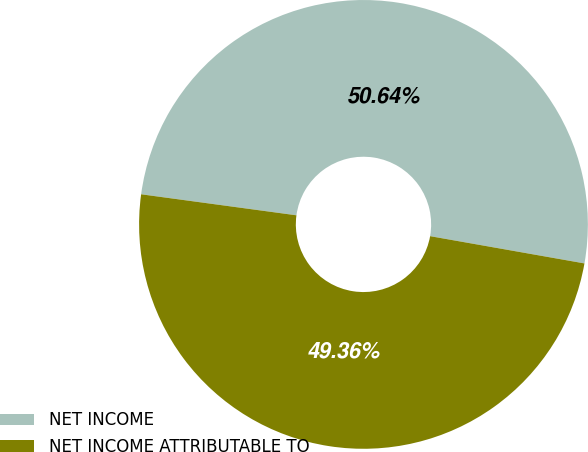Convert chart. <chart><loc_0><loc_0><loc_500><loc_500><pie_chart><fcel>NET INCOME<fcel>NET INCOME ATTRIBUTABLE TO<nl><fcel>50.64%<fcel>49.36%<nl></chart> 